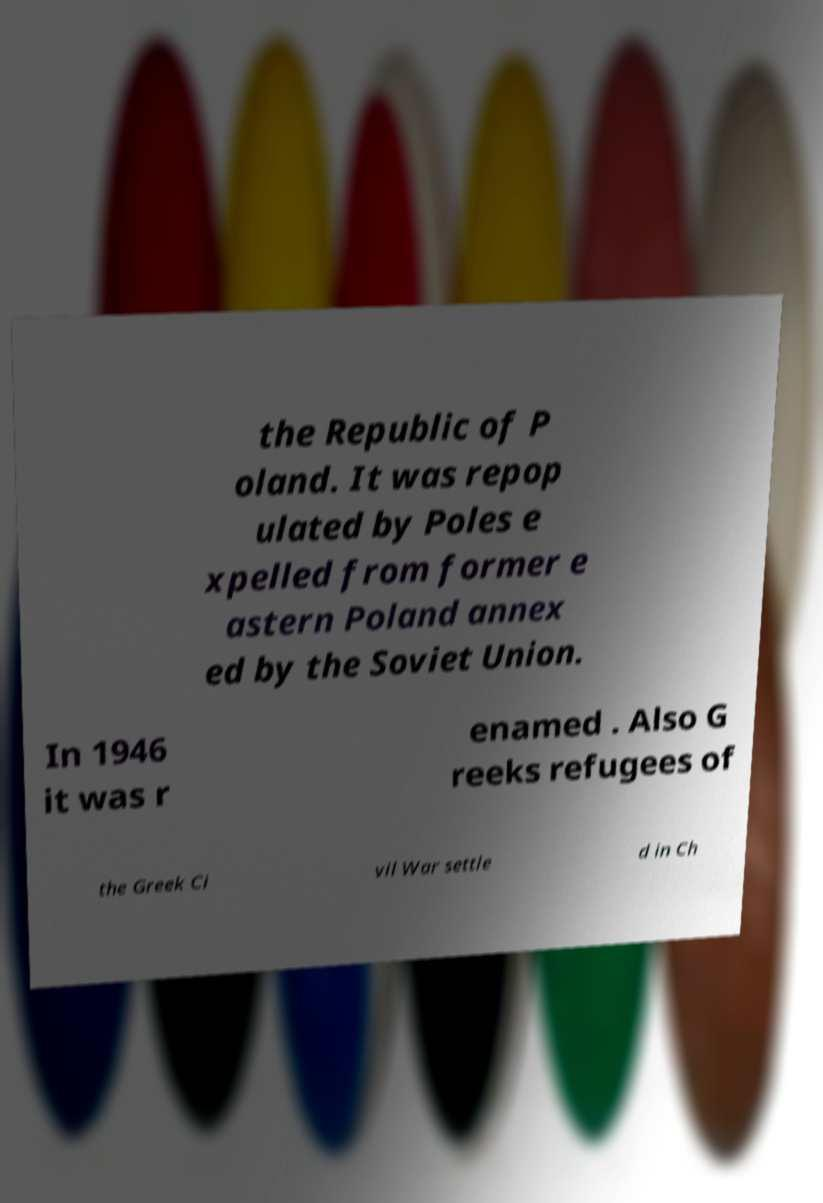Could you assist in decoding the text presented in this image and type it out clearly? the Republic of P oland. It was repop ulated by Poles e xpelled from former e astern Poland annex ed by the Soviet Union. In 1946 it was r enamed . Also G reeks refugees of the Greek Ci vil War settle d in Ch 